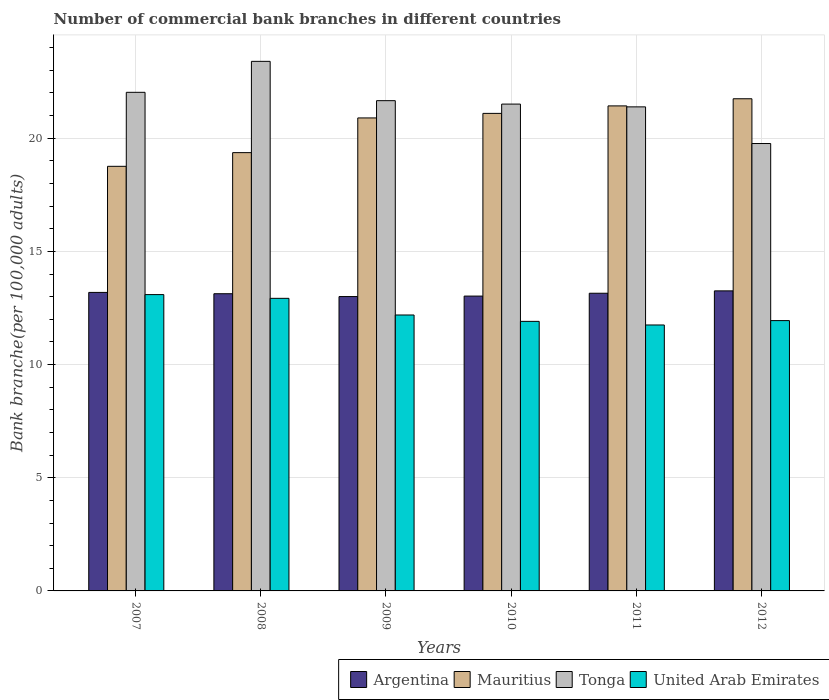How many different coloured bars are there?
Provide a short and direct response. 4. How many groups of bars are there?
Give a very brief answer. 6. How many bars are there on the 1st tick from the left?
Offer a terse response. 4. How many bars are there on the 4th tick from the right?
Ensure brevity in your answer.  4. In how many cases, is the number of bars for a given year not equal to the number of legend labels?
Offer a terse response. 0. What is the number of commercial bank branches in United Arab Emirates in 2008?
Offer a very short reply. 12.93. Across all years, what is the maximum number of commercial bank branches in Mauritius?
Make the answer very short. 21.74. Across all years, what is the minimum number of commercial bank branches in Tonga?
Offer a terse response. 19.77. In which year was the number of commercial bank branches in United Arab Emirates maximum?
Provide a short and direct response. 2007. In which year was the number of commercial bank branches in Tonga minimum?
Offer a terse response. 2012. What is the total number of commercial bank branches in Argentina in the graph?
Your answer should be very brief. 78.76. What is the difference between the number of commercial bank branches in United Arab Emirates in 2007 and that in 2008?
Provide a short and direct response. 0.17. What is the difference between the number of commercial bank branches in Mauritius in 2008 and the number of commercial bank branches in Tonga in 2007?
Offer a terse response. -2.66. What is the average number of commercial bank branches in Tonga per year?
Your answer should be very brief. 21.63. In the year 2011, what is the difference between the number of commercial bank branches in United Arab Emirates and number of commercial bank branches in Argentina?
Your answer should be compact. -1.4. What is the ratio of the number of commercial bank branches in Argentina in 2011 to that in 2012?
Make the answer very short. 0.99. What is the difference between the highest and the second highest number of commercial bank branches in Mauritius?
Provide a succinct answer. 0.32. What is the difference between the highest and the lowest number of commercial bank branches in Argentina?
Make the answer very short. 0.25. Is the sum of the number of commercial bank branches in Tonga in 2008 and 2009 greater than the maximum number of commercial bank branches in Argentina across all years?
Give a very brief answer. Yes. Is it the case that in every year, the sum of the number of commercial bank branches in Argentina and number of commercial bank branches in United Arab Emirates is greater than the sum of number of commercial bank branches in Tonga and number of commercial bank branches in Mauritius?
Give a very brief answer. No. What does the 4th bar from the left in 2010 represents?
Offer a very short reply. United Arab Emirates. What does the 1st bar from the right in 2008 represents?
Your answer should be compact. United Arab Emirates. Are all the bars in the graph horizontal?
Make the answer very short. No. Does the graph contain any zero values?
Make the answer very short. No. Where does the legend appear in the graph?
Your answer should be compact. Bottom right. How many legend labels are there?
Make the answer very short. 4. What is the title of the graph?
Ensure brevity in your answer.  Number of commercial bank branches in different countries. Does "Sub-Saharan Africa (developing only)" appear as one of the legend labels in the graph?
Provide a short and direct response. No. What is the label or title of the X-axis?
Ensure brevity in your answer.  Years. What is the label or title of the Y-axis?
Offer a terse response. Bank branche(per 100,0 adults). What is the Bank branche(per 100,000 adults) in Argentina in 2007?
Provide a short and direct response. 13.19. What is the Bank branche(per 100,000 adults) in Mauritius in 2007?
Make the answer very short. 18.76. What is the Bank branche(per 100,000 adults) in Tonga in 2007?
Ensure brevity in your answer.  22.03. What is the Bank branche(per 100,000 adults) of United Arab Emirates in 2007?
Ensure brevity in your answer.  13.09. What is the Bank branche(per 100,000 adults) in Argentina in 2008?
Make the answer very short. 13.13. What is the Bank branche(per 100,000 adults) of Mauritius in 2008?
Keep it short and to the point. 19.36. What is the Bank branche(per 100,000 adults) in Tonga in 2008?
Your response must be concise. 23.4. What is the Bank branche(per 100,000 adults) in United Arab Emirates in 2008?
Offer a very short reply. 12.93. What is the Bank branche(per 100,000 adults) of Argentina in 2009?
Provide a succinct answer. 13.01. What is the Bank branche(per 100,000 adults) of Mauritius in 2009?
Give a very brief answer. 20.9. What is the Bank branche(per 100,000 adults) in Tonga in 2009?
Offer a terse response. 21.66. What is the Bank branche(per 100,000 adults) in United Arab Emirates in 2009?
Give a very brief answer. 12.19. What is the Bank branche(per 100,000 adults) in Argentina in 2010?
Your response must be concise. 13.03. What is the Bank branche(per 100,000 adults) in Mauritius in 2010?
Keep it short and to the point. 21.1. What is the Bank branche(per 100,000 adults) of Tonga in 2010?
Keep it short and to the point. 21.51. What is the Bank branche(per 100,000 adults) in United Arab Emirates in 2010?
Your response must be concise. 11.91. What is the Bank branche(per 100,000 adults) in Argentina in 2011?
Your answer should be compact. 13.15. What is the Bank branche(per 100,000 adults) of Mauritius in 2011?
Provide a succinct answer. 21.43. What is the Bank branche(per 100,000 adults) of Tonga in 2011?
Your response must be concise. 21.39. What is the Bank branche(per 100,000 adults) in United Arab Emirates in 2011?
Ensure brevity in your answer.  11.75. What is the Bank branche(per 100,000 adults) of Argentina in 2012?
Your answer should be very brief. 13.26. What is the Bank branche(per 100,000 adults) of Mauritius in 2012?
Keep it short and to the point. 21.74. What is the Bank branche(per 100,000 adults) of Tonga in 2012?
Your response must be concise. 19.77. What is the Bank branche(per 100,000 adults) in United Arab Emirates in 2012?
Make the answer very short. 11.94. Across all years, what is the maximum Bank branche(per 100,000 adults) in Argentina?
Provide a succinct answer. 13.26. Across all years, what is the maximum Bank branche(per 100,000 adults) in Mauritius?
Provide a succinct answer. 21.74. Across all years, what is the maximum Bank branche(per 100,000 adults) of Tonga?
Offer a very short reply. 23.4. Across all years, what is the maximum Bank branche(per 100,000 adults) in United Arab Emirates?
Make the answer very short. 13.09. Across all years, what is the minimum Bank branche(per 100,000 adults) in Argentina?
Keep it short and to the point. 13.01. Across all years, what is the minimum Bank branche(per 100,000 adults) of Mauritius?
Provide a succinct answer. 18.76. Across all years, what is the minimum Bank branche(per 100,000 adults) of Tonga?
Offer a very short reply. 19.77. Across all years, what is the minimum Bank branche(per 100,000 adults) in United Arab Emirates?
Keep it short and to the point. 11.75. What is the total Bank branche(per 100,000 adults) in Argentina in the graph?
Your answer should be compact. 78.76. What is the total Bank branche(per 100,000 adults) in Mauritius in the graph?
Provide a short and direct response. 123.3. What is the total Bank branche(per 100,000 adults) of Tonga in the graph?
Your answer should be very brief. 129.75. What is the total Bank branche(per 100,000 adults) in United Arab Emirates in the graph?
Offer a terse response. 73.81. What is the difference between the Bank branche(per 100,000 adults) in Argentina in 2007 and that in 2008?
Your answer should be compact. 0.06. What is the difference between the Bank branche(per 100,000 adults) in Mauritius in 2007 and that in 2008?
Ensure brevity in your answer.  -0.61. What is the difference between the Bank branche(per 100,000 adults) of Tonga in 2007 and that in 2008?
Keep it short and to the point. -1.37. What is the difference between the Bank branche(per 100,000 adults) in United Arab Emirates in 2007 and that in 2008?
Ensure brevity in your answer.  0.17. What is the difference between the Bank branche(per 100,000 adults) of Argentina in 2007 and that in 2009?
Make the answer very short. 0.18. What is the difference between the Bank branche(per 100,000 adults) in Mauritius in 2007 and that in 2009?
Ensure brevity in your answer.  -2.14. What is the difference between the Bank branche(per 100,000 adults) in Tonga in 2007 and that in 2009?
Provide a short and direct response. 0.37. What is the difference between the Bank branche(per 100,000 adults) in United Arab Emirates in 2007 and that in 2009?
Provide a short and direct response. 0.9. What is the difference between the Bank branche(per 100,000 adults) in Argentina in 2007 and that in 2010?
Provide a short and direct response. 0.16. What is the difference between the Bank branche(per 100,000 adults) of Mauritius in 2007 and that in 2010?
Offer a terse response. -2.34. What is the difference between the Bank branche(per 100,000 adults) in Tonga in 2007 and that in 2010?
Your answer should be compact. 0.52. What is the difference between the Bank branche(per 100,000 adults) in United Arab Emirates in 2007 and that in 2010?
Give a very brief answer. 1.18. What is the difference between the Bank branche(per 100,000 adults) in Argentina in 2007 and that in 2011?
Your response must be concise. 0.04. What is the difference between the Bank branche(per 100,000 adults) of Mauritius in 2007 and that in 2011?
Offer a terse response. -2.67. What is the difference between the Bank branche(per 100,000 adults) of Tonga in 2007 and that in 2011?
Offer a terse response. 0.64. What is the difference between the Bank branche(per 100,000 adults) in United Arab Emirates in 2007 and that in 2011?
Your answer should be very brief. 1.34. What is the difference between the Bank branche(per 100,000 adults) in Argentina in 2007 and that in 2012?
Your answer should be very brief. -0.07. What is the difference between the Bank branche(per 100,000 adults) of Mauritius in 2007 and that in 2012?
Give a very brief answer. -2.98. What is the difference between the Bank branche(per 100,000 adults) of Tonga in 2007 and that in 2012?
Ensure brevity in your answer.  2.26. What is the difference between the Bank branche(per 100,000 adults) of United Arab Emirates in 2007 and that in 2012?
Provide a short and direct response. 1.15. What is the difference between the Bank branche(per 100,000 adults) in Argentina in 2008 and that in 2009?
Make the answer very short. 0.13. What is the difference between the Bank branche(per 100,000 adults) of Mauritius in 2008 and that in 2009?
Provide a succinct answer. -1.53. What is the difference between the Bank branche(per 100,000 adults) in Tonga in 2008 and that in 2009?
Ensure brevity in your answer.  1.74. What is the difference between the Bank branche(per 100,000 adults) of United Arab Emirates in 2008 and that in 2009?
Offer a terse response. 0.74. What is the difference between the Bank branche(per 100,000 adults) in Argentina in 2008 and that in 2010?
Ensure brevity in your answer.  0.1. What is the difference between the Bank branche(per 100,000 adults) of Mauritius in 2008 and that in 2010?
Provide a succinct answer. -1.73. What is the difference between the Bank branche(per 100,000 adults) of Tonga in 2008 and that in 2010?
Provide a short and direct response. 1.89. What is the difference between the Bank branche(per 100,000 adults) in United Arab Emirates in 2008 and that in 2010?
Your response must be concise. 1.02. What is the difference between the Bank branche(per 100,000 adults) of Argentina in 2008 and that in 2011?
Offer a very short reply. -0.02. What is the difference between the Bank branche(per 100,000 adults) of Mauritius in 2008 and that in 2011?
Offer a terse response. -2.06. What is the difference between the Bank branche(per 100,000 adults) in Tonga in 2008 and that in 2011?
Make the answer very short. 2.01. What is the difference between the Bank branche(per 100,000 adults) in United Arab Emirates in 2008 and that in 2011?
Make the answer very short. 1.18. What is the difference between the Bank branche(per 100,000 adults) of Argentina in 2008 and that in 2012?
Ensure brevity in your answer.  -0.13. What is the difference between the Bank branche(per 100,000 adults) of Mauritius in 2008 and that in 2012?
Your response must be concise. -2.38. What is the difference between the Bank branche(per 100,000 adults) of Tonga in 2008 and that in 2012?
Make the answer very short. 3.63. What is the difference between the Bank branche(per 100,000 adults) of Argentina in 2009 and that in 2010?
Your response must be concise. -0.02. What is the difference between the Bank branche(per 100,000 adults) of Mauritius in 2009 and that in 2010?
Your answer should be compact. -0.2. What is the difference between the Bank branche(per 100,000 adults) in Tonga in 2009 and that in 2010?
Keep it short and to the point. 0.15. What is the difference between the Bank branche(per 100,000 adults) in United Arab Emirates in 2009 and that in 2010?
Offer a very short reply. 0.28. What is the difference between the Bank branche(per 100,000 adults) in Argentina in 2009 and that in 2011?
Your response must be concise. -0.15. What is the difference between the Bank branche(per 100,000 adults) of Mauritius in 2009 and that in 2011?
Ensure brevity in your answer.  -0.53. What is the difference between the Bank branche(per 100,000 adults) in Tonga in 2009 and that in 2011?
Offer a very short reply. 0.27. What is the difference between the Bank branche(per 100,000 adults) of United Arab Emirates in 2009 and that in 2011?
Your answer should be very brief. 0.44. What is the difference between the Bank branche(per 100,000 adults) in Argentina in 2009 and that in 2012?
Your answer should be compact. -0.25. What is the difference between the Bank branche(per 100,000 adults) in Mauritius in 2009 and that in 2012?
Make the answer very short. -0.85. What is the difference between the Bank branche(per 100,000 adults) of Tonga in 2009 and that in 2012?
Your answer should be compact. 1.89. What is the difference between the Bank branche(per 100,000 adults) of United Arab Emirates in 2009 and that in 2012?
Your answer should be very brief. 0.25. What is the difference between the Bank branche(per 100,000 adults) in Argentina in 2010 and that in 2011?
Keep it short and to the point. -0.13. What is the difference between the Bank branche(per 100,000 adults) in Mauritius in 2010 and that in 2011?
Keep it short and to the point. -0.33. What is the difference between the Bank branche(per 100,000 adults) of Tonga in 2010 and that in 2011?
Keep it short and to the point. 0.12. What is the difference between the Bank branche(per 100,000 adults) of United Arab Emirates in 2010 and that in 2011?
Provide a succinct answer. 0.16. What is the difference between the Bank branche(per 100,000 adults) in Argentina in 2010 and that in 2012?
Offer a very short reply. -0.23. What is the difference between the Bank branche(per 100,000 adults) of Mauritius in 2010 and that in 2012?
Provide a short and direct response. -0.65. What is the difference between the Bank branche(per 100,000 adults) of Tonga in 2010 and that in 2012?
Ensure brevity in your answer.  1.74. What is the difference between the Bank branche(per 100,000 adults) of United Arab Emirates in 2010 and that in 2012?
Provide a short and direct response. -0.03. What is the difference between the Bank branche(per 100,000 adults) in Argentina in 2011 and that in 2012?
Keep it short and to the point. -0.1. What is the difference between the Bank branche(per 100,000 adults) in Mauritius in 2011 and that in 2012?
Your answer should be very brief. -0.32. What is the difference between the Bank branche(per 100,000 adults) of Tonga in 2011 and that in 2012?
Your answer should be very brief. 1.62. What is the difference between the Bank branche(per 100,000 adults) of United Arab Emirates in 2011 and that in 2012?
Offer a very short reply. -0.19. What is the difference between the Bank branche(per 100,000 adults) in Argentina in 2007 and the Bank branche(per 100,000 adults) in Mauritius in 2008?
Your answer should be very brief. -6.18. What is the difference between the Bank branche(per 100,000 adults) in Argentina in 2007 and the Bank branche(per 100,000 adults) in Tonga in 2008?
Your answer should be compact. -10.21. What is the difference between the Bank branche(per 100,000 adults) in Argentina in 2007 and the Bank branche(per 100,000 adults) in United Arab Emirates in 2008?
Keep it short and to the point. 0.26. What is the difference between the Bank branche(per 100,000 adults) in Mauritius in 2007 and the Bank branche(per 100,000 adults) in Tonga in 2008?
Give a very brief answer. -4.64. What is the difference between the Bank branche(per 100,000 adults) in Mauritius in 2007 and the Bank branche(per 100,000 adults) in United Arab Emirates in 2008?
Give a very brief answer. 5.83. What is the difference between the Bank branche(per 100,000 adults) of Tonga in 2007 and the Bank branche(per 100,000 adults) of United Arab Emirates in 2008?
Keep it short and to the point. 9.1. What is the difference between the Bank branche(per 100,000 adults) of Argentina in 2007 and the Bank branche(per 100,000 adults) of Mauritius in 2009?
Your response must be concise. -7.71. What is the difference between the Bank branche(per 100,000 adults) of Argentina in 2007 and the Bank branche(per 100,000 adults) of Tonga in 2009?
Provide a short and direct response. -8.47. What is the difference between the Bank branche(per 100,000 adults) of Mauritius in 2007 and the Bank branche(per 100,000 adults) of Tonga in 2009?
Provide a succinct answer. -2.9. What is the difference between the Bank branche(per 100,000 adults) in Mauritius in 2007 and the Bank branche(per 100,000 adults) in United Arab Emirates in 2009?
Make the answer very short. 6.57. What is the difference between the Bank branche(per 100,000 adults) in Tonga in 2007 and the Bank branche(per 100,000 adults) in United Arab Emirates in 2009?
Your response must be concise. 9.84. What is the difference between the Bank branche(per 100,000 adults) in Argentina in 2007 and the Bank branche(per 100,000 adults) in Mauritius in 2010?
Offer a very short reply. -7.91. What is the difference between the Bank branche(per 100,000 adults) of Argentina in 2007 and the Bank branche(per 100,000 adults) of Tonga in 2010?
Keep it short and to the point. -8.32. What is the difference between the Bank branche(per 100,000 adults) in Argentina in 2007 and the Bank branche(per 100,000 adults) in United Arab Emirates in 2010?
Keep it short and to the point. 1.28. What is the difference between the Bank branche(per 100,000 adults) of Mauritius in 2007 and the Bank branche(per 100,000 adults) of Tonga in 2010?
Ensure brevity in your answer.  -2.75. What is the difference between the Bank branche(per 100,000 adults) of Mauritius in 2007 and the Bank branche(per 100,000 adults) of United Arab Emirates in 2010?
Ensure brevity in your answer.  6.85. What is the difference between the Bank branche(per 100,000 adults) in Tonga in 2007 and the Bank branche(per 100,000 adults) in United Arab Emirates in 2010?
Your answer should be compact. 10.12. What is the difference between the Bank branche(per 100,000 adults) in Argentina in 2007 and the Bank branche(per 100,000 adults) in Mauritius in 2011?
Provide a short and direct response. -8.24. What is the difference between the Bank branche(per 100,000 adults) in Argentina in 2007 and the Bank branche(per 100,000 adults) in Tonga in 2011?
Make the answer very short. -8.2. What is the difference between the Bank branche(per 100,000 adults) in Argentina in 2007 and the Bank branche(per 100,000 adults) in United Arab Emirates in 2011?
Offer a terse response. 1.44. What is the difference between the Bank branche(per 100,000 adults) of Mauritius in 2007 and the Bank branche(per 100,000 adults) of Tonga in 2011?
Provide a short and direct response. -2.63. What is the difference between the Bank branche(per 100,000 adults) in Mauritius in 2007 and the Bank branche(per 100,000 adults) in United Arab Emirates in 2011?
Provide a succinct answer. 7.01. What is the difference between the Bank branche(per 100,000 adults) of Tonga in 2007 and the Bank branche(per 100,000 adults) of United Arab Emirates in 2011?
Ensure brevity in your answer.  10.28. What is the difference between the Bank branche(per 100,000 adults) in Argentina in 2007 and the Bank branche(per 100,000 adults) in Mauritius in 2012?
Give a very brief answer. -8.56. What is the difference between the Bank branche(per 100,000 adults) of Argentina in 2007 and the Bank branche(per 100,000 adults) of Tonga in 2012?
Your answer should be compact. -6.58. What is the difference between the Bank branche(per 100,000 adults) of Argentina in 2007 and the Bank branche(per 100,000 adults) of United Arab Emirates in 2012?
Provide a succinct answer. 1.25. What is the difference between the Bank branche(per 100,000 adults) of Mauritius in 2007 and the Bank branche(per 100,000 adults) of Tonga in 2012?
Your response must be concise. -1.01. What is the difference between the Bank branche(per 100,000 adults) in Mauritius in 2007 and the Bank branche(per 100,000 adults) in United Arab Emirates in 2012?
Offer a very short reply. 6.82. What is the difference between the Bank branche(per 100,000 adults) in Tonga in 2007 and the Bank branche(per 100,000 adults) in United Arab Emirates in 2012?
Offer a very short reply. 10.09. What is the difference between the Bank branche(per 100,000 adults) of Argentina in 2008 and the Bank branche(per 100,000 adults) of Mauritius in 2009?
Your response must be concise. -7.77. What is the difference between the Bank branche(per 100,000 adults) of Argentina in 2008 and the Bank branche(per 100,000 adults) of Tonga in 2009?
Your response must be concise. -8.53. What is the difference between the Bank branche(per 100,000 adults) in Argentina in 2008 and the Bank branche(per 100,000 adults) in United Arab Emirates in 2009?
Offer a very short reply. 0.94. What is the difference between the Bank branche(per 100,000 adults) of Mauritius in 2008 and the Bank branche(per 100,000 adults) of Tonga in 2009?
Offer a terse response. -2.3. What is the difference between the Bank branche(per 100,000 adults) of Mauritius in 2008 and the Bank branche(per 100,000 adults) of United Arab Emirates in 2009?
Your answer should be compact. 7.17. What is the difference between the Bank branche(per 100,000 adults) of Tonga in 2008 and the Bank branche(per 100,000 adults) of United Arab Emirates in 2009?
Your response must be concise. 11.21. What is the difference between the Bank branche(per 100,000 adults) of Argentina in 2008 and the Bank branche(per 100,000 adults) of Mauritius in 2010?
Make the answer very short. -7.97. What is the difference between the Bank branche(per 100,000 adults) in Argentina in 2008 and the Bank branche(per 100,000 adults) in Tonga in 2010?
Offer a very short reply. -8.38. What is the difference between the Bank branche(per 100,000 adults) in Argentina in 2008 and the Bank branche(per 100,000 adults) in United Arab Emirates in 2010?
Provide a succinct answer. 1.22. What is the difference between the Bank branche(per 100,000 adults) in Mauritius in 2008 and the Bank branche(per 100,000 adults) in Tonga in 2010?
Provide a succinct answer. -2.14. What is the difference between the Bank branche(per 100,000 adults) in Mauritius in 2008 and the Bank branche(per 100,000 adults) in United Arab Emirates in 2010?
Your response must be concise. 7.46. What is the difference between the Bank branche(per 100,000 adults) of Tonga in 2008 and the Bank branche(per 100,000 adults) of United Arab Emirates in 2010?
Your response must be concise. 11.49. What is the difference between the Bank branche(per 100,000 adults) of Argentina in 2008 and the Bank branche(per 100,000 adults) of Mauritius in 2011?
Your answer should be very brief. -8.3. What is the difference between the Bank branche(per 100,000 adults) of Argentina in 2008 and the Bank branche(per 100,000 adults) of Tonga in 2011?
Your answer should be very brief. -8.26. What is the difference between the Bank branche(per 100,000 adults) of Argentina in 2008 and the Bank branche(per 100,000 adults) of United Arab Emirates in 2011?
Your response must be concise. 1.38. What is the difference between the Bank branche(per 100,000 adults) in Mauritius in 2008 and the Bank branche(per 100,000 adults) in Tonga in 2011?
Provide a short and direct response. -2.02. What is the difference between the Bank branche(per 100,000 adults) in Mauritius in 2008 and the Bank branche(per 100,000 adults) in United Arab Emirates in 2011?
Ensure brevity in your answer.  7.61. What is the difference between the Bank branche(per 100,000 adults) in Tonga in 2008 and the Bank branche(per 100,000 adults) in United Arab Emirates in 2011?
Offer a terse response. 11.65. What is the difference between the Bank branche(per 100,000 adults) of Argentina in 2008 and the Bank branche(per 100,000 adults) of Mauritius in 2012?
Make the answer very short. -8.61. What is the difference between the Bank branche(per 100,000 adults) in Argentina in 2008 and the Bank branche(per 100,000 adults) in Tonga in 2012?
Make the answer very short. -6.64. What is the difference between the Bank branche(per 100,000 adults) of Argentina in 2008 and the Bank branche(per 100,000 adults) of United Arab Emirates in 2012?
Offer a very short reply. 1.19. What is the difference between the Bank branche(per 100,000 adults) of Mauritius in 2008 and the Bank branche(per 100,000 adults) of Tonga in 2012?
Make the answer very short. -0.4. What is the difference between the Bank branche(per 100,000 adults) of Mauritius in 2008 and the Bank branche(per 100,000 adults) of United Arab Emirates in 2012?
Provide a short and direct response. 7.42. What is the difference between the Bank branche(per 100,000 adults) of Tonga in 2008 and the Bank branche(per 100,000 adults) of United Arab Emirates in 2012?
Offer a terse response. 11.45. What is the difference between the Bank branche(per 100,000 adults) in Argentina in 2009 and the Bank branche(per 100,000 adults) in Mauritius in 2010?
Offer a very short reply. -8.09. What is the difference between the Bank branche(per 100,000 adults) of Argentina in 2009 and the Bank branche(per 100,000 adults) of Tonga in 2010?
Keep it short and to the point. -8.5. What is the difference between the Bank branche(per 100,000 adults) in Argentina in 2009 and the Bank branche(per 100,000 adults) in United Arab Emirates in 2010?
Your answer should be compact. 1.1. What is the difference between the Bank branche(per 100,000 adults) of Mauritius in 2009 and the Bank branche(per 100,000 adults) of Tonga in 2010?
Offer a terse response. -0.61. What is the difference between the Bank branche(per 100,000 adults) in Mauritius in 2009 and the Bank branche(per 100,000 adults) in United Arab Emirates in 2010?
Offer a terse response. 8.99. What is the difference between the Bank branche(per 100,000 adults) in Tonga in 2009 and the Bank branche(per 100,000 adults) in United Arab Emirates in 2010?
Give a very brief answer. 9.75. What is the difference between the Bank branche(per 100,000 adults) of Argentina in 2009 and the Bank branche(per 100,000 adults) of Mauritius in 2011?
Your response must be concise. -8.42. What is the difference between the Bank branche(per 100,000 adults) of Argentina in 2009 and the Bank branche(per 100,000 adults) of Tonga in 2011?
Keep it short and to the point. -8.38. What is the difference between the Bank branche(per 100,000 adults) in Argentina in 2009 and the Bank branche(per 100,000 adults) in United Arab Emirates in 2011?
Give a very brief answer. 1.26. What is the difference between the Bank branche(per 100,000 adults) in Mauritius in 2009 and the Bank branche(per 100,000 adults) in Tonga in 2011?
Offer a very short reply. -0.49. What is the difference between the Bank branche(per 100,000 adults) in Mauritius in 2009 and the Bank branche(per 100,000 adults) in United Arab Emirates in 2011?
Give a very brief answer. 9.15. What is the difference between the Bank branche(per 100,000 adults) in Tonga in 2009 and the Bank branche(per 100,000 adults) in United Arab Emirates in 2011?
Make the answer very short. 9.91. What is the difference between the Bank branche(per 100,000 adults) of Argentina in 2009 and the Bank branche(per 100,000 adults) of Mauritius in 2012?
Provide a short and direct response. -8.74. What is the difference between the Bank branche(per 100,000 adults) in Argentina in 2009 and the Bank branche(per 100,000 adults) in Tonga in 2012?
Offer a very short reply. -6.76. What is the difference between the Bank branche(per 100,000 adults) in Argentina in 2009 and the Bank branche(per 100,000 adults) in United Arab Emirates in 2012?
Ensure brevity in your answer.  1.06. What is the difference between the Bank branche(per 100,000 adults) in Mauritius in 2009 and the Bank branche(per 100,000 adults) in Tonga in 2012?
Your answer should be compact. 1.13. What is the difference between the Bank branche(per 100,000 adults) of Mauritius in 2009 and the Bank branche(per 100,000 adults) of United Arab Emirates in 2012?
Your response must be concise. 8.95. What is the difference between the Bank branche(per 100,000 adults) of Tonga in 2009 and the Bank branche(per 100,000 adults) of United Arab Emirates in 2012?
Your response must be concise. 9.72. What is the difference between the Bank branche(per 100,000 adults) of Argentina in 2010 and the Bank branche(per 100,000 adults) of Mauritius in 2011?
Offer a very short reply. -8.4. What is the difference between the Bank branche(per 100,000 adults) in Argentina in 2010 and the Bank branche(per 100,000 adults) in Tonga in 2011?
Provide a short and direct response. -8.36. What is the difference between the Bank branche(per 100,000 adults) of Argentina in 2010 and the Bank branche(per 100,000 adults) of United Arab Emirates in 2011?
Your answer should be very brief. 1.28. What is the difference between the Bank branche(per 100,000 adults) of Mauritius in 2010 and the Bank branche(per 100,000 adults) of Tonga in 2011?
Provide a short and direct response. -0.29. What is the difference between the Bank branche(per 100,000 adults) in Mauritius in 2010 and the Bank branche(per 100,000 adults) in United Arab Emirates in 2011?
Give a very brief answer. 9.35. What is the difference between the Bank branche(per 100,000 adults) in Tonga in 2010 and the Bank branche(per 100,000 adults) in United Arab Emirates in 2011?
Your answer should be compact. 9.76. What is the difference between the Bank branche(per 100,000 adults) of Argentina in 2010 and the Bank branche(per 100,000 adults) of Mauritius in 2012?
Provide a succinct answer. -8.72. What is the difference between the Bank branche(per 100,000 adults) in Argentina in 2010 and the Bank branche(per 100,000 adults) in Tonga in 2012?
Your response must be concise. -6.74. What is the difference between the Bank branche(per 100,000 adults) of Argentina in 2010 and the Bank branche(per 100,000 adults) of United Arab Emirates in 2012?
Give a very brief answer. 1.08. What is the difference between the Bank branche(per 100,000 adults) in Mauritius in 2010 and the Bank branche(per 100,000 adults) in Tonga in 2012?
Your answer should be very brief. 1.33. What is the difference between the Bank branche(per 100,000 adults) of Mauritius in 2010 and the Bank branche(per 100,000 adults) of United Arab Emirates in 2012?
Your answer should be compact. 9.16. What is the difference between the Bank branche(per 100,000 adults) in Tonga in 2010 and the Bank branche(per 100,000 adults) in United Arab Emirates in 2012?
Provide a short and direct response. 9.57. What is the difference between the Bank branche(per 100,000 adults) in Argentina in 2011 and the Bank branche(per 100,000 adults) in Mauritius in 2012?
Give a very brief answer. -8.59. What is the difference between the Bank branche(per 100,000 adults) in Argentina in 2011 and the Bank branche(per 100,000 adults) in Tonga in 2012?
Provide a short and direct response. -6.61. What is the difference between the Bank branche(per 100,000 adults) in Argentina in 2011 and the Bank branche(per 100,000 adults) in United Arab Emirates in 2012?
Make the answer very short. 1.21. What is the difference between the Bank branche(per 100,000 adults) in Mauritius in 2011 and the Bank branche(per 100,000 adults) in Tonga in 2012?
Your answer should be very brief. 1.66. What is the difference between the Bank branche(per 100,000 adults) of Mauritius in 2011 and the Bank branche(per 100,000 adults) of United Arab Emirates in 2012?
Provide a succinct answer. 9.49. What is the difference between the Bank branche(per 100,000 adults) of Tonga in 2011 and the Bank branche(per 100,000 adults) of United Arab Emirates in 2012?
Your response must be concise. 9.44. What is the average Bank branche(per 100,000 adults) in Argentina per year?
Your response must be concise. 13.13. What is the average Bank branche(per 100,000 adults) in Mauritius per year?
Keep it short and to the point. 20.55. What is the average Bank branche(per 100,000 adults) in Tonga per year?
Provide a succinct answer. 21.63. What is the average Bank branche(per 100,000 adults) in United Arab Emirates per year?
Your response must be concise. 12.3. In the year 2007, what is the difference between the Bank branche(per 100,000 adults) in Argentina and Bank branche(per 100,000 adults) in Mauritius?
Provide a succinct answer. -5.57. In the year 2007, what is the difference between the Bank branche(per 100,000 adults) of Argentina and Bank branche(per 100,000 adults) of Tonga?
Provide a succinct answer. -8.84. In the year 2007, what is the difference between the Bank branche(per 100,000 adults) in Argentina and Bank branche(per 100,000 adults) in United Arab Emirates?
Your answer should be compact. 0.1. In the year 2007, what is the difference between the Bank branche(per 100,000 adults) in Mauritius and Bank branche(per 100,000 adults) in Tonga?
Offer a terse response. -3.27. In the year 2007, what is the difference between the Bank branche(per 100,000 adults) in Mauritius and Bank branche(per 100,000 adults) in United Arab Emirates?
Give a very brief answer. 5.67. In the year 2007, what is the difference between the Bank branche(per 100,000 adults) in Tonga and Bank branche(per 100,000 adults) in United Arab Emirates?
Your response must be concise. 8.94. In the year 2008, what is the difference between the Bank branche(per 100,000 adults) in Argentina and Bank branche(per 100,000 adults) in Mauritius?
Offer a terse response. -6.23. In the year 2008, what is the difference between the Bank branche(per 100,000 adults) in Argentina and Bank branche(per 100,000 adults) in Tonga?
Give a very brief answer. -10.27. In the year 2008, what is the difference between the Bank branche(per 100,000 adults) of Argentina and Bank branche(per 100,000 adults) of United Arab Emirates?
Your answer should be very brief. 0.2. In the year 2008, what is the difference between the Bank branche(per 100,000 adults) of Mauritius and Bank branche(per 100,000 adults) of Tonga?
Offer a terse response. -4.03. In the year 2008, what is the difference between the Bank branche(per 100,000 adults) of Mauritius and Bank branche(per 100,000 adults) of United Arab Emirates?
Offer a terse response. 6.44. In the year 2008, what is the difference between the Bank branche(per 100,000 adults) of Tonga and Bank branche(per 100,000 adults) of United Arab Emirates?
Ensure brevity in your answer.  10.47. In the year 2009, what is the difference between the Bank branche(per 100,000 adults) in Argentina and Bank branche(per 100,000 adults) in Mauritius?
Keep it short and to the point. -7.89. In the year 2009, what is the difference between the Bank branche(per 100,000 adults) of Argentina and Bank branche(per 100,000 adults) of Tonga?
Your answer should be compact. -8.66. In the year 2009, what is the difference between the Bank branche(per 100,000 adults) of Argentina and Bank branche(per 100,000 adults) of United Arab Emirates?
Ensure brevity in your answer.  0.81. In the year 2009, what is the difference between the Bank branche(per 100,000 adults) of Mauritius and Bank branche(per 100,000 adults) of Tonga?
Keep it short and to the point. -0.76. In the year 2009, what is the difference between the Bank branche(per 100,000 adults) of Mauritius and Bank branche(per 100,000 adults) of United Arab Emirates?
Your answer should be very brief. 8.71. In the year 2009, what is the difference between the Bank branche(per 100,000 adults) of Tonga and Bank branche(per 100,000 adults) of United Arab Emirates?
Give a very brief answer. 9.47. In the year 2010, what is the difference between the Bank branche(per 100,000 adults) in Argentina and Bank branche(per 100,000 adults) in Mauritius?
Offer a very short reply. -8.07. In the year 2010, what is the difference between the Bank branche(per 100,000 adults) in Argentina and Bank branche(per 100,000 adults) in Tonga?
Offer a terse response. -8.48. In the year 2010, what is the difference between the Bank branche(per 100,000 adults) in Argentina and Bank branche(per 100,000 adults) in United Arab Emirates?
Your answer should be very brief. 1.12. In the year 2010, what is the difference between the Bank branche(per 100,000 adults) of Mauritius and Bank branche(per 100,000 adults) of Tonga?
Make the answer very short. -0.41. In the year 2010, what is the difference between the Bank branche(per 100,000 adults) of Mauritius and Bank branche(per 100,000 adults) of United Arab Emirates?
Ensure brevity in your answer.  9.19. In the year 2011, what is the difference between the Bank branche(per 100,000 adults) of Argentina and Bank branche(per 100,000 adults) of Mauritius?
Your answer should be compact. -8.28. In the year 2011, what is the difference between the Bank branche(per 100,000 adults) of Argentina and Bank branche(per 100,000 adults) of Tonga?
Your answer should be very brief. -8.23. In the year 2011, what is the difference between the Bank branche(per 100,000 adults) in Argentina and Bank branche(per 100,000 adults) in United Arab Emirates?
Keep it short and to the point. 1.4. In the year 2011, what is the difference between the Bank branche(per 100,000 adults) of Mauritius and Bank branche(per 100,000 adults) of Tonga?
Make the answer very short. 0.04. In the year 2011, what is the difference between the Bank branche(per 100,000 adults) in Mauritius and Bank branche(per 100,000 adults) in United Arab Emirates?
Offer a terse response. 9.68. In the year 2011, what is the difference between the Bank branche(per 100,000 adults) of Tonga and Bank branche(per 100,000 adults) of United Arab Emirates?
Offer a very short reply. 9.64. In the year 2012, what is the difference between the Bank branche(per 100,000 adults) in Argentina and Bank branche(per 100,000 adults) in Mauritius?
Ensure brevity in your answer.  -8.49. In the year 2012, what is the difference between the Bank branche(per 100,000 adults) in Argentina and Bank branche(per 100,000 adults) in Tonga?
Your answer should be compact. -6.51. In the year 2012, what is the difference between the Bank branche(per 100,000 adults) in Argentina and Bank branche(per 100,000 adults) in United Arab Emirates?
Offer a very short reply. 1.31. In the year 2012, what is the difference between the Bank branche(per 100,000 adults) of Mauritius and Bank branche(per 100,000 adults) of Tonga?
Ensure brevity in your answer.  1.98. In the year 2012, what is the difference between the Bank branche(per 100,000 adults) in Mauritius and Bank branche(per 100,000 adults) in United Arab Emirates?
Give a very brief answer. 9.8. In the year 2012, what is the difference between the Bank branche(per 100,000 adults) in Tonga and Bank branche(per 100,000 adults) in United Arab Emirates?
Offer a very short reply. 7.82. What is the ratio of the Bank branche(per 100,000 adults) in Argentina in 2007 to that in 2008?
Provide a short and direct response. 1. What is the ratio of the Bank branche(per 100,000 adults) of Mauritius in 2007 to that in 2008?
Ensure brevity in your answer.  0.97. What is the ratio of the Bank branche(per 100,000 adults) in Tonga in 2007 to that in 2008?
Provide a succinct answer. 0.94. What is the ratio of the Bank branche(per 100,000 adults) of United Arab Emirates in 2007 to that in 2008?
Offer a terse response. 1.01. What is the ratio of the Bank branche(per 100,000 adults) of Argentina in 2007 to that in 2009?
Your answer should be very brief. 1.01. What is the ratio of the Bank branche(per 100,000 adults) in Mauritius in 2007 to that in 2009?
Make the answer very short. 0.9. What is the ratio of the Bank branche(per 100,000 adults) of Tonga in 2007 to that in 2009?
Ensure brevity in your answer.  1.02. What is the ratio of the Bank branche(per 100,000 adults) of United Arab Emirates in 2007 to that in 2009?
Your response must be concise. 1.07. What is the ratio of the Bank branche(per 100,000 adults) in Argentina in 2007 to that in 2010?
Offer a very short reply. 1.01. What is the ratio of the Bank branche(per 100,000 adults) of Mauritius in 2007 to that in 2010?
Make the answer very short. 0.89. What is the ratio of the Bank branche(per 100,000 adults) of Tonga in 2007 to that in 2010?
Offer a very short reply. 1.02. What is the ratio of the Bank branche(per 100,000 adults) in United Arab Emirates in 2007 to that in 2010?
Your answer should be very brief. 1.1. What is the ratio of the Bank branche(per 100,000 adults) of Mauritius in 2007 to that in 2011?
Give a very brief answer. 0.88. What is the ratio of the Bank branche(per 100,000 adults) in United Arab Emirates in 2007 to that in 2011?
Provide a short and direct response. 1.11. What is the ratio of the Bank branche(per 100,000 adults) in Argentina in 2007 to that in 2012?
Keep it short and to the point. 0.99. What is the ratio of the Bank branche(per 100,000 adults) in Mauritius in 2007 to that in 2012?
Ensure brevity in your answer.  0.86. What is the ratio of the Bank branche(per 100,000 adults) in Tonga in 2007 to that in 2012?
Make the answer very short. 1.11. What is the ratio of the Bank branche(per 100,000 adults) of United Arab Emirates in 2007 to that in 2012?
Provide a succinct answer. 1.1. What is the ratio of the Bank branche(per 100,000 adults) in Argentina in 2008 to that in 2009?
Your answer should be compact. 1.01. What is the ratio of the Bank branche(per 100,000 adults) of Mauritius in 2008 to that in 2009?
Offer a very short reply. 0.93. What is the ratio of the Bank branche(per 100,000 adults) in Tonga in 2008 to that in 2009?
Ensure brevity in your answer.  1.08. What is the ratio of the Bank branche(per 100,000 adults) in United Arab Emirates in 2008 to that in 2009?
Make the answer very short. 1.06. What is the ratio of the Bank branche(per 100,000 adults) of Argentina in 2008 to that in 2010?
Your answer should be very brief. 1.01. What is the ratio of the Bank branche(per 100,000 adults) of Mauritius in 2008 to that in 2010?
Ensure brevity in your answer.  0.92. What is the ratio of the Bank branche(per 100,000 adults) in Tonga in 2008 to that in 2010?
Your answer should be very brief. 1.09. What is the ratio of the Bank branche(per 100,000 adults) in United Arab Emirates in 2008 to that in 2010?
Your answer should be compact. 1.09. What is the ratio of the Bank branche(per 100,000 adults) of Mauritius in 2008 to that in 2011?
Ensure brevity in your answer.  0.9. What is the ratio of the Bank branche(per 100,000 adults) of Tonga in 2008 to that in 2011?
Offer a very short reply. 1.09. What is the ratio of the Bank branche(per 100,000 adults) in United Arab Emirates in 2008 to that in 2011?
Offer a terse response. 1.1. What is the ratio of the Bank branche(per 100,000 adults) of Argentina in 2008 to that in 2012?
Provide a succinct answer. 0.99. What is the ratio of the Bank branche(per 100,000 adults) of Mauritius in 2008 to that in 2012?
Provide a short and direct response. 0.89. What is the ratio of the Bank branche(per 100,000 adults) in Tonga in 2008 to that in 2012?
Your answer should be compact. 1.18. What is the ratio of the Bank branche(per 100,000 adults) in United Arab Emirates in 2008 to that in 2012?
Keep it short and to the point. 1.08. What is the ratio of the Bank branche(per 100,000 adults) of Tonga in 2009 to that in 2010?
Your response must be concise. 1.01. What is the ratio of the Bank branche(per 100,000 adults) in United Arab Emirates in 2009 to that in 2010?
Give a very brief answer. 1.02. What is the ratio of the Bank branche(per 100,000 adults) in Argentina in 2009 to that in 2011?
Your response must be concise. 0.99. What is the ratio of the Bank branche(per 100,000 adults) in Mauritius in 2009 to that in 2011?
Keep it short and to the point. 0.98. What is the ratio of the Bank branche(per 100,000 adults) of Tonga in 2009 to that in 2011?
Provide a succinct answer. 1.01. What is the ratio of the Bank branche(per 100,000 adults) of United Arab Emirates in 2009 to that in 2011?
Provide a succinct answer. 1.04. What is the ratio of the Bank branche(per 100,000 adults) of Mauritius in 2009 to that in 2012?
Keep it short and to the point. 0.96. What is the ratio of the Bank branche(per 100,000 adults) in Tonga in 2009 to that in 2012?
Give a very brief answer. 1.1. What is the ratio of the Bank branche(per 100,000 adults) in United Arab Emirates in 2009 to that in 2012?
Provide a short and direct response. 1.02. What is the ratio of the Bank branche(per 100,000 adults) in Argentina in 2010 to that in 2011?
Ensure brevity in your answer.  0.99. What is the ratio of the Bank branche(per 100,000 adults) of Mauritius in 2010 to that in 2011?
Provide a short and direct response. 0.98. What is the ratio of the Bank branche(per 100,000 adults) of Tonga in 2010 to that in 2011?
Offer a terse response. 1.01. What is the ratio of the Bank branche(per 100,000 adults) of United Arab Emirates in 2010 to that in 2011?
Provide a succinct answer. 1.01. What is the ratio of the Bank branche(per 100,000 adults) in Argentina in 2010 to that in 2012?
Keep it short and to the point. 0.98. What is the ratio of the Bank branche(per 100,000 adults) of Mauritius in 2010 to that in 2012?
Give a very brief answer. 0.97. What is the ratio of the Bank branche(per 100,000 adults) in Tonga in 2010 to that in 2012?
Your answer should be very brief. 1.09. What is the ratio of the Bank branche(per 100,000 adults) of Mauritius in 2011 to that in 2012?
Your answer should be very brief. 0.99. What is the ratio of the Bank branche(per 100,000 adults) in Tonga in 2011 to that in 2012?
Ensure brevity in your answer.  1.08. What is the ratio of the Bank branche(per 100,000 adults) of United Arab Emirates in 2011 to that in 2012?
Keep it short and to the point. 0.98. What is the difference between the highest and the second highest Bank branche(per 100,000 adults) of Argentina?
Provide a short and direct response. 0.07. What is the difference between the highest and the second highest Bank branche(per 100,000 adults) in Mauritius?
Your answer should be very brief. 0.32. What is the difference between the highest and the second highest Bank branche(per 100,000 adults) of Tonga?
Keep it short and to the point. 1.37. What is the difference between the highest and the second highest Bank branche(per 100,000 adults) in United Arab Emirates?
Your response must be concise. 0.17. What is the difference between the highest and the lowest Bank branche(per 100,000 adults) in Argentina?
Your answer should be compact. 0.25. What is the difference between the highest and the lowest Bank branche(per 100,000 adults) in Mauritius?
Keep it short and to the point. 2.98. What is the difference between the highest and the lowest Bank branche(per 100,000 adults) in Tonga?
Your answer should be very brief. 3.63. What is the difference between the highest and the lowest Bank branche(per 100,000 adults) in United Arab Emirates?
Offer a very short reply. 1.34. 